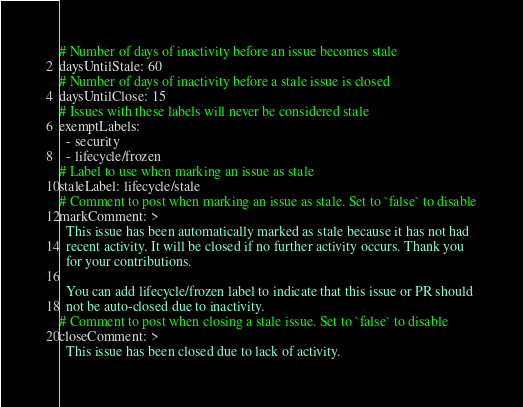Convert code to text. <code><loc_0><loc_0><loc_500><loc_500><_YAML_># Number of days of inactivity before an issue becomes stale
daysUntilStale: 60
# Number of days of inactivity before a stale issue is closed
daysUntilClose: 15
# Issues with these labels will never be considered stale
exemptLabels:
  - security
  - lifecycle/frozen
# Label to use when marking an issue as stale
staleLabel: lifecycle/stale
# Comment to post when marking an issue as stale. Set to `false` to disable
markComment: >
  This issue has been automatically marked as stale because it has not had
  recent activity. It will be closed if no further activity occurs. Thank you
  for your contributions.

  You can add lifecycle/frozen label to indicate that this issue or PR should
  not be auto-closed due to inactivity.
# Comment to post when closing a stale issue. Set to `false` to disable
closeComment: >
  This issue has been closed due to lack of activity.
</code> 